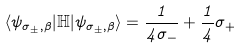<formula> <loc_0><loc_0><loc_500><loc_500>\langle \psi _ { \sigma _ { \pm } , \beta } | { \mathbb { H } } | \psi _ { \sigma _ { \pm } , \beta } \rangle = \frac { 1 } { 4 \sigma _ { - } } + \frac { 1 } { 4 } \sigma _ { + }</formula> 